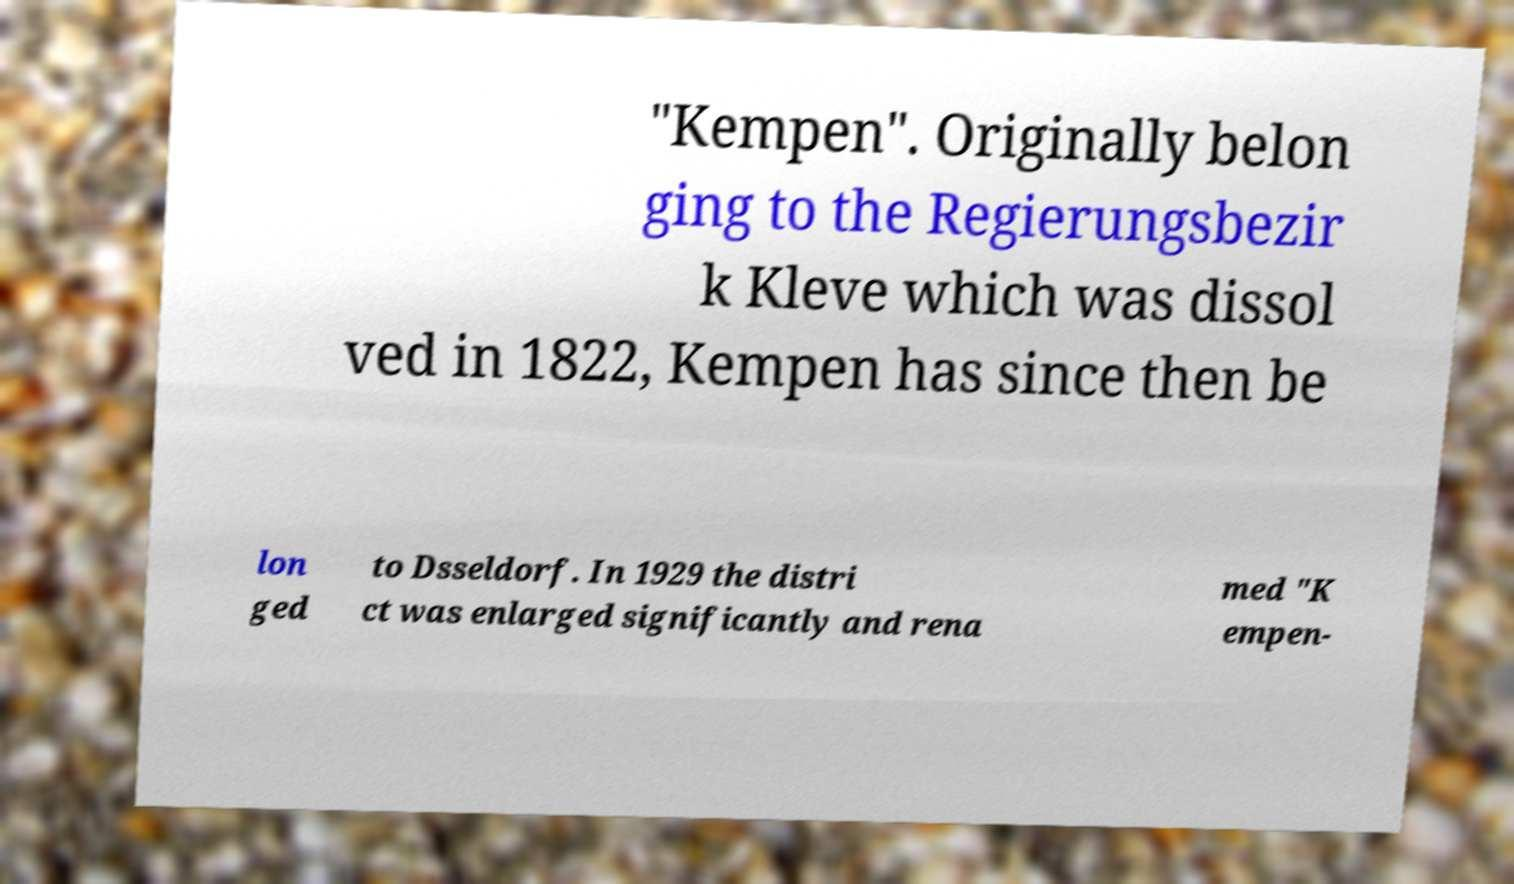What messages or text are displayed in this image? I need them in a readable, typed format. "Kempen". Originally belon ging to the Regierungsbezir k Kleve which was dissol ved in 1822, Kempen has since then be lon ged to Dsseldorf. In 1929 the distri ct was enlarged significantly and rena med "K empen- 